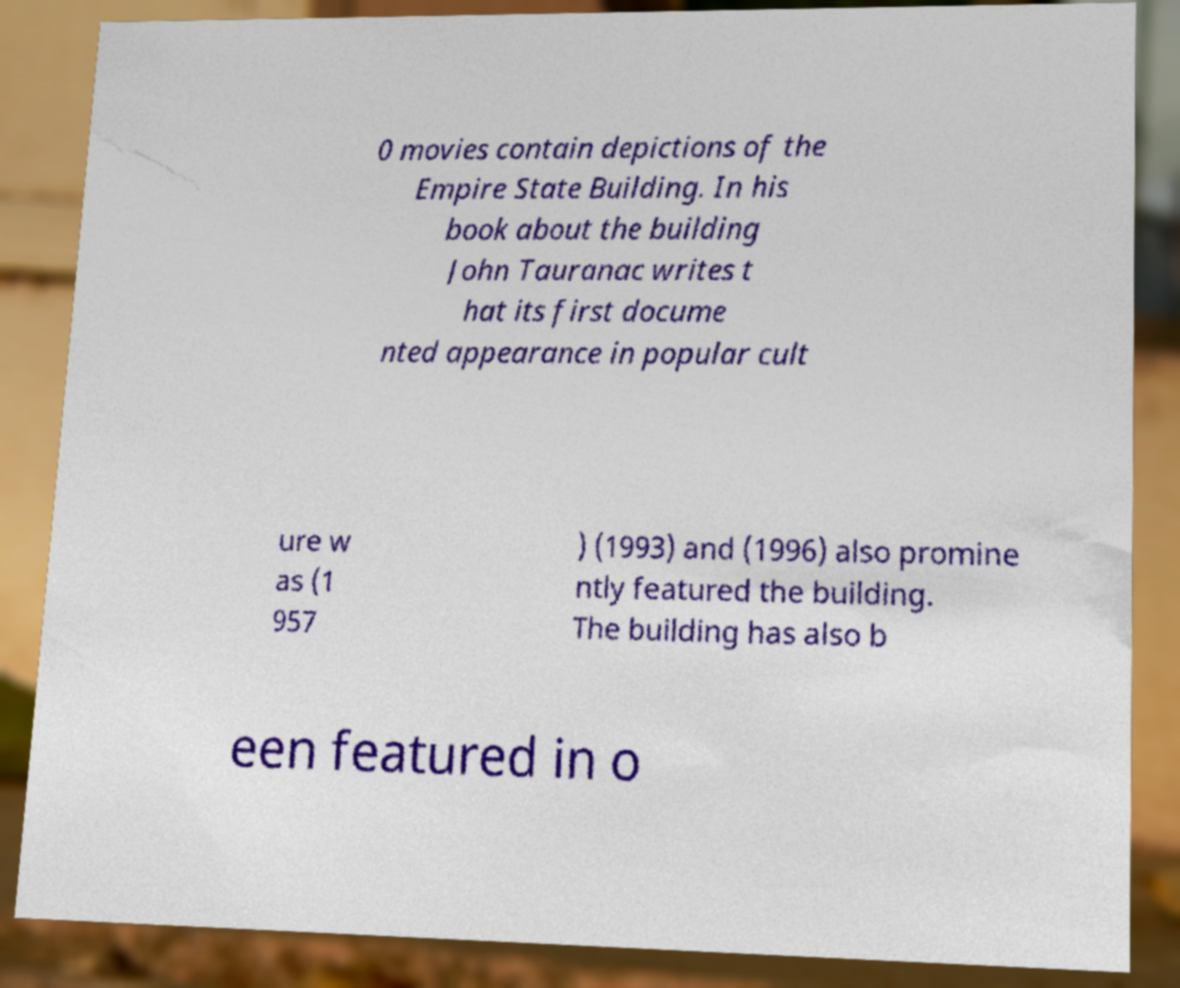Can you accurately transcribe the text from the provided image for me? 0 movies contain depictions of the Empire State Building. In his book about the building John Tauranac writes t hat its first docume nted appearance in popular cult ure w as (1 957 ) (1993) and (1996) also promine ntly featured the building. The building has also b een featured in o 